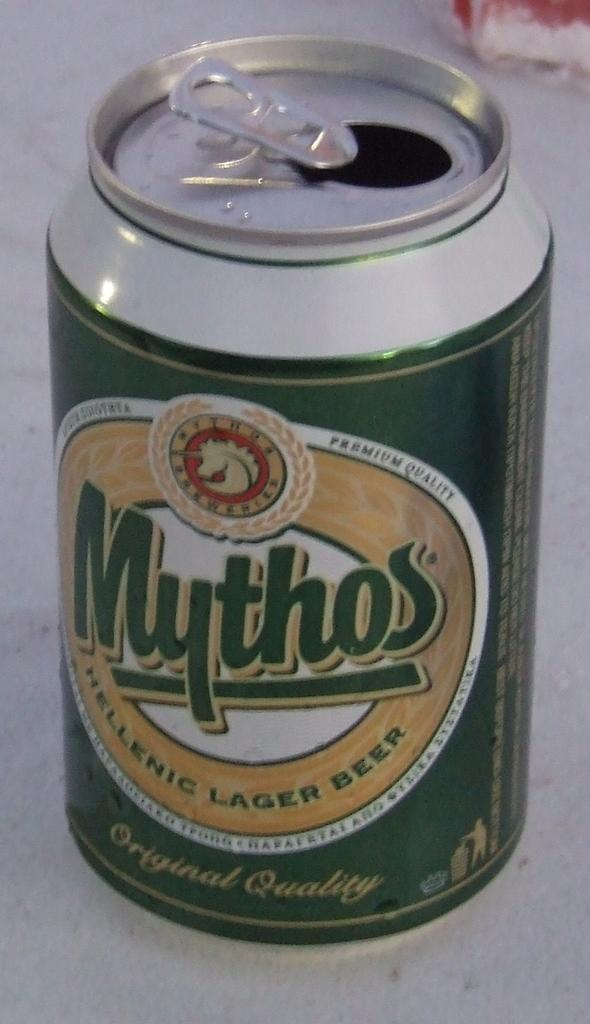Provide a one-sentence caption for the provided image. The beer can of Mythos has already been opened. 